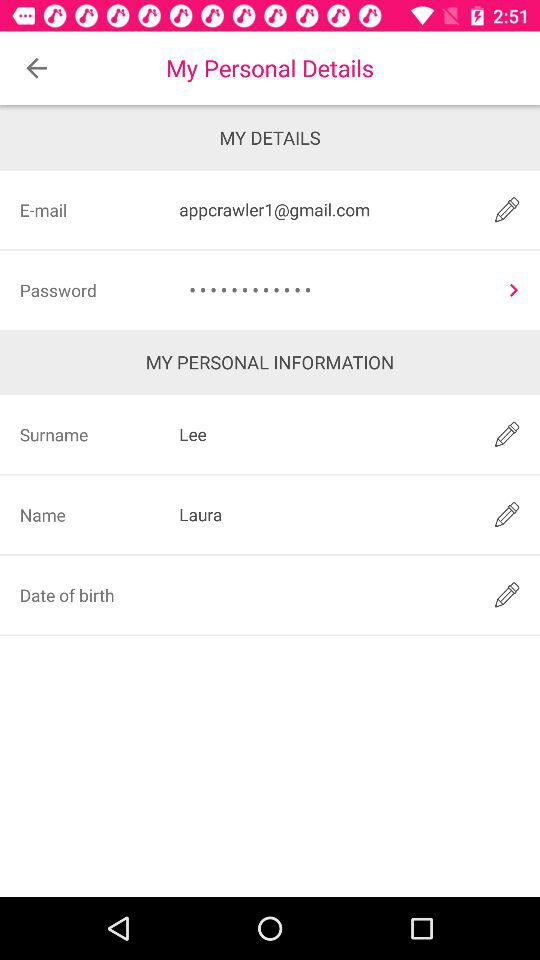What is the name of the person? The name of the person is Laura. 